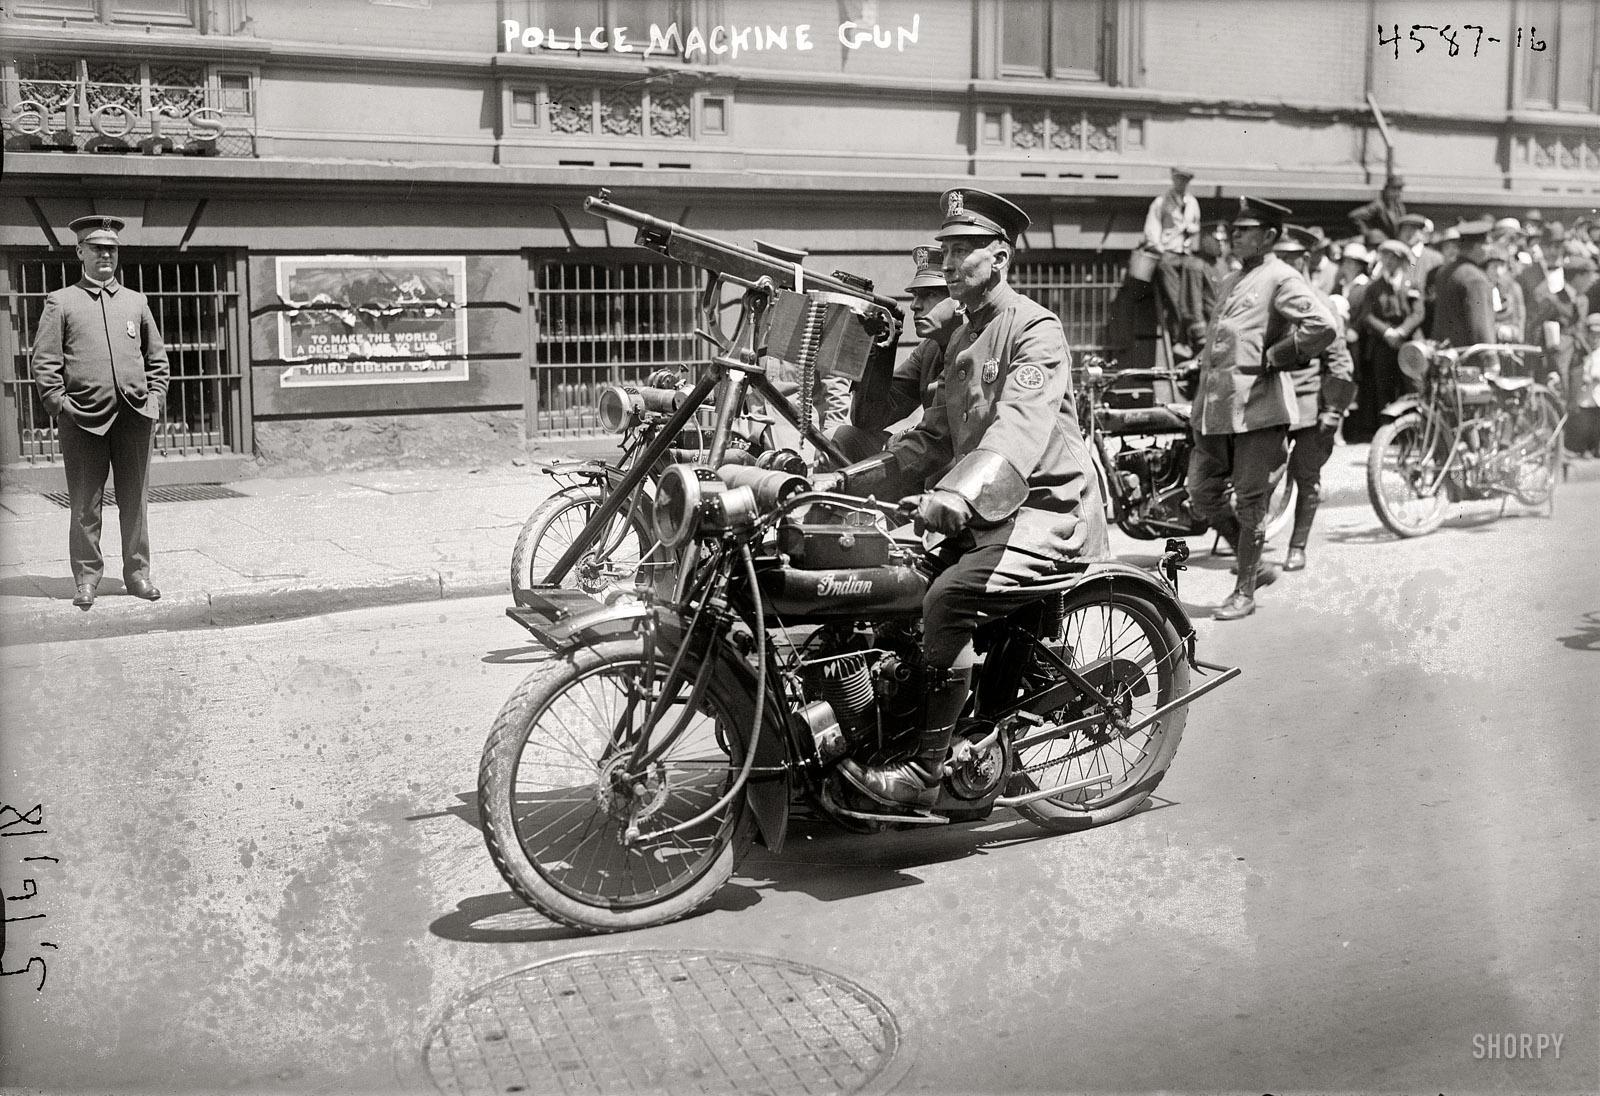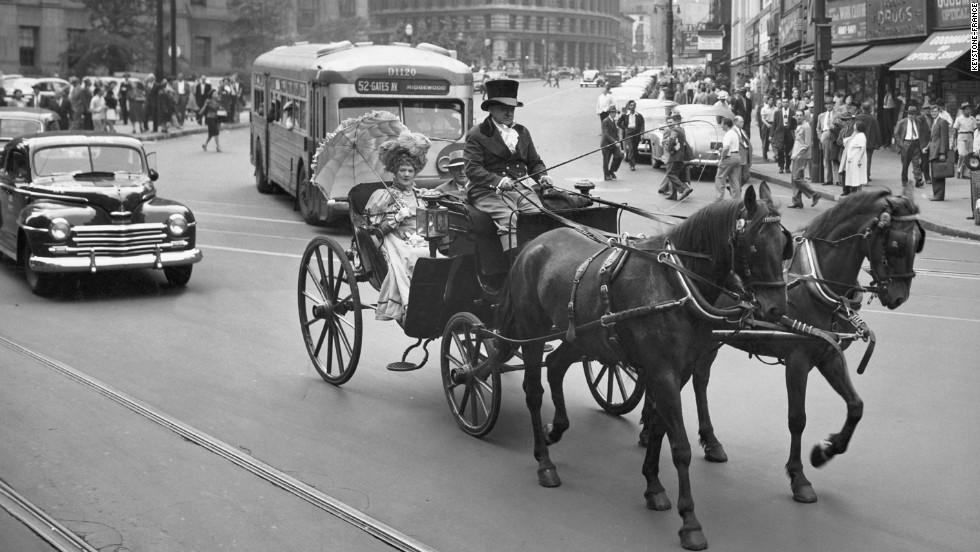The first image is the image on the left, the second image is the image on the right. Assess this claim about the two images: "In the foreground of the right image, at least one dark horse is pulling a four-wheeled carriage driven by a man in a hat, suit and white shirt, holding a stick.". Correct or not? Answer yes or no. Yes. The first image is the image on the left, the second image is the image on the right. Given the left and right images, does the statement "In at least one image there are two men being pulled on a sled by one horse." hold true? Answer yes or no. No. 